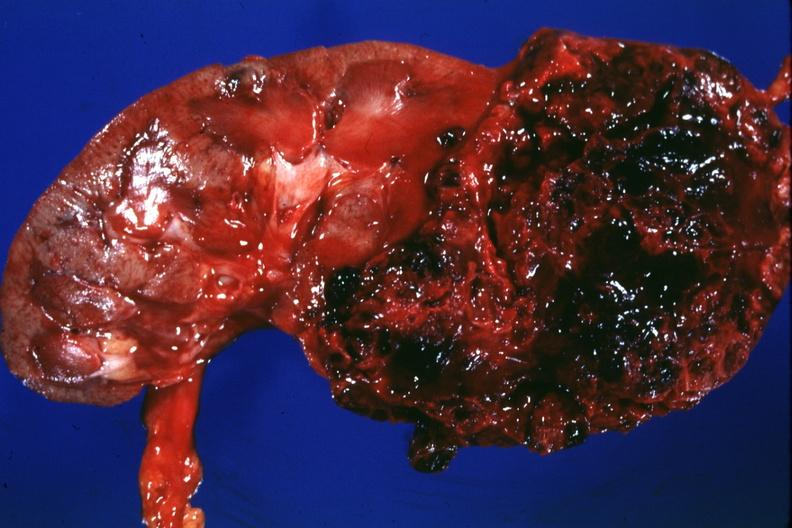where is this?
Answer the question using a single word or phrase. Urinary 